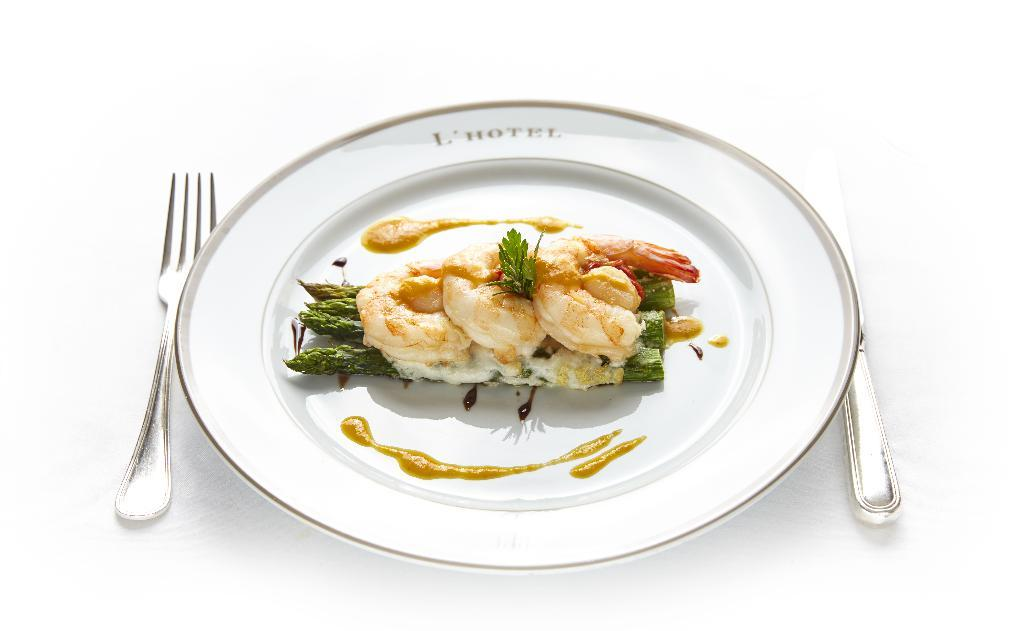What is on the plate that is visible in the image? There is a plate with food items in the image. What utensil is located on the left side of the image? There is a fork on the left side of the image. What type of volcano can be seen erupting in the background of the image? There is no volcano present in the image; it only features a plate with food items and a fork. How many cattle are grazing in the foreground of the image? There are no cattle present in the image; it only features a plate with food items and a fork. 